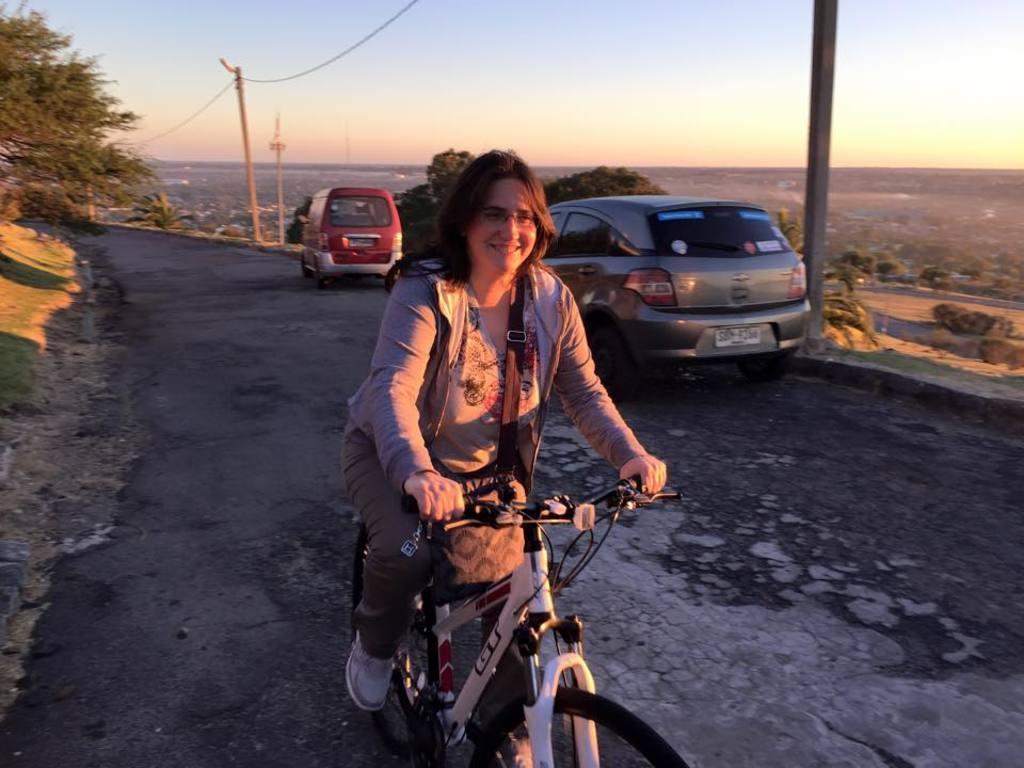Can you describe this image briefly? In the center of the image there is a woman on the bicycle. There is a road on which there are cars. In the background of the image there are trees and electric poles. 